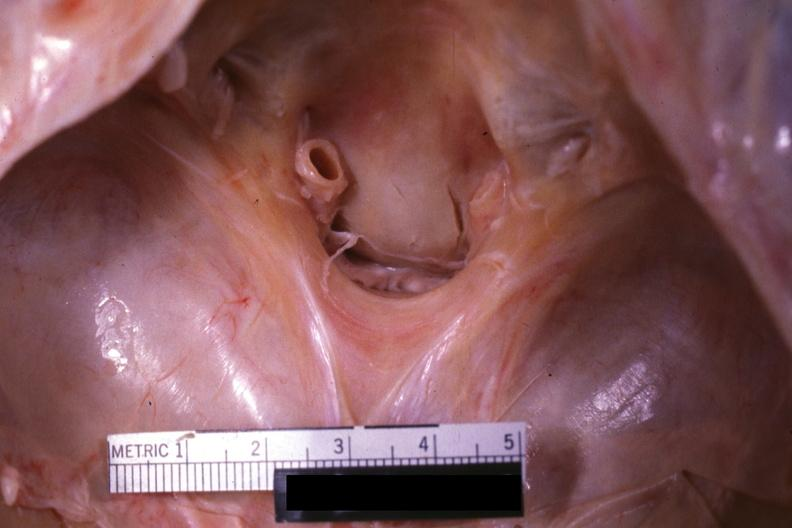s odontoid process subluxation with narrowing of foramen magnum present?
Answer the question using a single word or phrase. Yes 